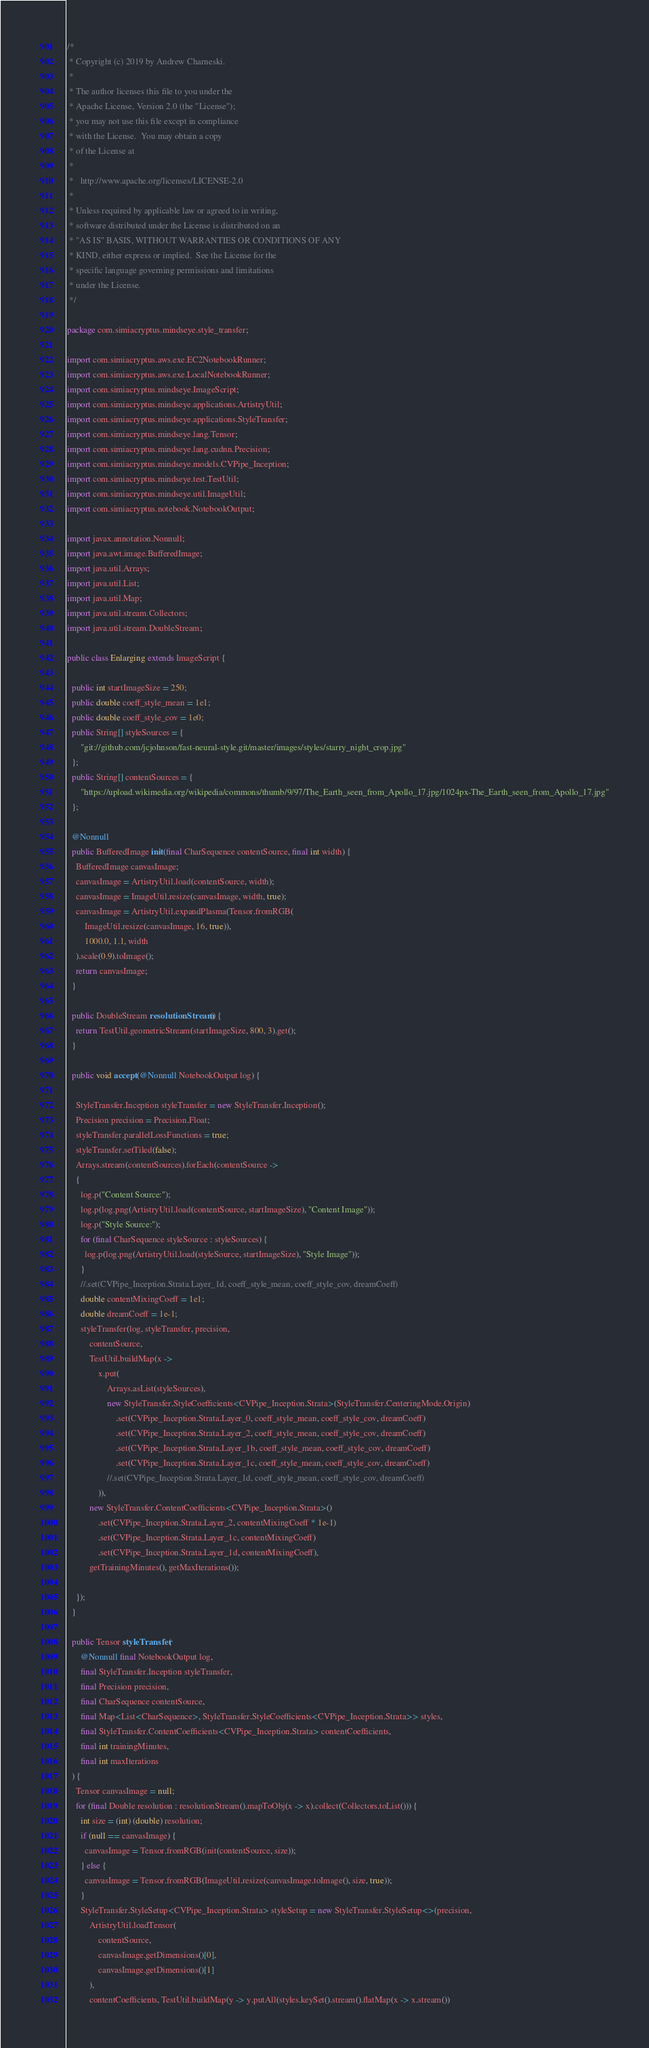Convert code to text. <code><loc_0><loc_0><loc_500><loc_500><_Java_>/*
 * Copyright (c) 2019 by Andrew Charneski.
 *
 * The author licenses this file to you under the
 * Apache License, Version 2.0 (the "License");
 * you may not use this file except in compliance
 * with the License.  You may obtain a copy
 * of the License at
 *
 *   http://www.apache.org/licenses/LICENSE-2.0
 *
 * Unless required by applicable law or agreed to in writing,
 * software distributed under the License is distributed on an
 * "AS IS" BASIS, WITHOUT WARRANTIES OR CONDITIONS OF ANY
 * KIND, either express or implied.  See the License for the
 * specific language governing permissions and limitations
 * under the License.
 */

package com.simiacryptus.mindseye.style_transfer;

import com.simiacryptus.aws.exe.EC2NotebookRunner;
import com.simiacryptus.aws.exe.LocalNotebookRunner;
import com.simiacryptus.mindseye.ImageScript;
import com.simiacryptus.mindseye.applications.ArtistryUtil;
import com.simiacryptus.mindseye.applications.StyleTransfer;
import com.simiacryptus.mindseye.lang.Tensor;
import com.simiacryptus.mindseye.lang.cudnn.Precision;
import com.simiacryptus.mindseye.models.CVPipe_Inception;
import com.simiacryptus.mindseye.test.TestUtil;
import com.simiacryptus.mindseye.util.ImageUtil;
import com.simiacryptus.notebook.NotebookOutput;

import javax.annotation.Nonnull;
import java.awt.image.BufferedImage;
import java.util.Arrays;
import java.util.List;
import java.util.Map;
import java.util.stream.Collectors;
import java.util.stream.DoubleStream;

public class Enlarging extends ImageScript {

  public int startImageSize = 250;
  public double coeff_style_mean = 1e1;
  public double coeff_style_cov = 1e0;
  public String[] styleSources = {
      "git://github.com/jcjohnson/fast-neural-style.git/master/images/styles/starry_night_crop.jpg"
  };
  public String[] contentSources = {
      "https://upload.wikimedia.org/wikipedia/commons/thumb/9/97/The_Earth_seen_from_Apollo_17.jpg/1024px-The_Earth_seen_from_Apollo_17.jpg"
  };

  @Nonnull
  public BufferedImage init(final CharSequence contentSource, final int width) {
    BufferedImage canvasImage;
    canvasImage = ArtistryUtil.load(contentSource, width);
    canvasImage = ImageUtil.resize(canvasImage, width, true);
    canvasImage = ArtistryUtil.expandPlasma(Tensor.fromRGB(
        ImageUtil.resize(canvasImage, 16, true)),
        1000.0, 1.1, width
    ).scale(0.9).toImage();
    return canvasImage;
  }

  public DoubleStream resolutionStream() {
    return TestUtil.geometricStream(startImageSize, 800, 3).get();
  }

  public void accept(@Nonnull NotebookOutput log) {

    StyleTransfer.Inception styleTransfer = new StyleTransfer.Inception();
    Precision precision = Precision.Float;
    styleTransfer.parallelLossFunctions = true;
    styleTransfer.setTiled(false);
    Arrays.stream(contentSources).forEach(contentSource ->
    {
      log.p("Content Source:");
      log.p(log.png(ArtistryUtil.load(contentSource, startImageSize), "Content Image"));
      log.p("Style Source:");
      for (final CharSequence styleSource : styleSources) {
        log.p(log.png(ArtistryUtil.load(styleSource, startImageSize), "Style Image"));
      }
      //.set(CVPipe_Inception.Strata.Layer_1d, coeff_style_mean, coeff_style_cov, dreamCoeff)
      double contentMixingCoeff = 1e1;
      double dreamCoeff = 1e-1;
      styleTransfer(log, styleTransfer, precision,
          contentSource,
          TestUtil.buildMap(x ->
              x.put(
                  Arrays.asList(styleSources),
                  new StyleTransfer.StyleCoefficients<CVPipe_Inception.Strata>(StyleTransfer.CenteringMode.Origin)
                      .set(CVPipe_Inception.Strata.Layer_0, coeff_style_mean, coeff_style_cov, dreamCoeff)
                      .set(CVPipe_Inception.Strata.Layer_2, coeff_style_mean, coeff_style_cov, dreamCoeff)
                      .set(CVPipe_Inception.Strata.Layer_1b, coeff_style_mean, coeff_style_cov, dreamCoeff)
                      .set(CVPipe_Inception.Strata.Layer_1c, coeff_style_mean, coeff_style_cov, dreamCoeff)
                  //.set(CVPipe_Inception.Strata.Layer_1d, coeff_style_mean, coeff_style_cov, dreamCoeff)
              )),
          new StyleTransfer.ContentCoefficients<CVPipe_Inception.Strata>()
              .set(CVPipe_Inception.Strata.Layer_2, contentMixingCoeff * 1e-1)
              .set(CVPipe_Inception.Strata.Layer_1c, contentMixingCoeff)
              .set(CVPipe_Inception.Strata.Layer_1d, contentMixingCoeff),
          getTrainingMinutes(), getMaxIterations());

    });
  }

  public Tensor styleTransfer(
      @Nonnull final NotebookOutput log,
      final StyleTransfer.Inception styleTransfer,
      final Precision precision,
      final CharSequence contentSource,
      final Map<List<CharSequence>, StyleTransfer.StyleCoefficients<CVPipe_Inception.Strata>> styles,
      final StyleTransfer.ContentCoefficients<CVPipe_Inception.Strata> contentCoefficients,
      final int trainingMinutes,
      final int maxIterations
  ) {
    Tensor canvasImage = null;
    for (final Double resolution : resolutionStream().mapToObj(x -> x).collect(Collectors.toList())) {
      int size = (int) (double) resolution;
      if (null == canvasImage) {
        canvasImage = Tensor.fromRGB(init(contentSource, size));
      } else {
        canvasImage = Tensor.fromRGB(ImageUtil.resize(canvasImage.toImage(), size, true));
      }
      StyleTransfer.StyleSetup<CVPipe_Inception.Strata> styleSetup = new StyleTransfer.StyleSetup<>(precision,
          ArtistryUtil.loadTensor(
              contentSource,
              canvasImage.getDimensions()[0],
              canvasImage.getDimensions()[1]
          ),
          contentCoefficients, TestUtil.buildMap(y -> y.putAll(styles.keySet().stream().flatMap(x -> x.stream())</code> 